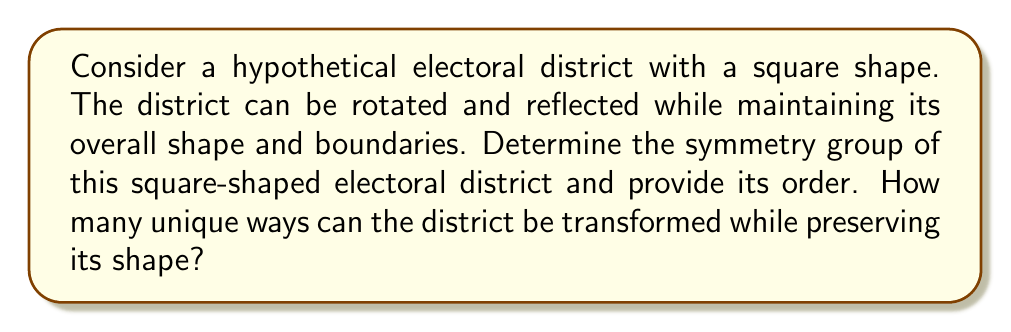Can you solve this math problem? To determine the symmetry group of the square-shaped electoral district, we need to consider all the transformations that preserve its shape and boundaries. Let's approach this step-by-step:

1. Rotational symmetries:
   The square can be rotated by 0°, 90°, 180°, and 270° (or equivalently, 0°, 90°, 180°, and -90°).
   This gives us 4 rotational symmetries.

2. Reflection symmetries:
   The square has 4 lines of reflection:
   - Two diagonal lines
   - One vertical line
   - One horizontal line

3. Combining these symmetries:
   We have 4 rotations and 4 reflections, giving us a total of 8 symmetries.

The symmetry group of a square is known as the dihedral group of order 8, denoted as $D_4$ or $D_8$ (depending on the notation convention).

To represent this group algebraically:
Let $r$ represent a 90° rotation clockwise, and $s$ represent a reflection across the vertical axis.

The elements of the group can be written as:
$$ \{e, r, r^2, r^3, s, sr, sr^2, sr^3\} $$

Where:
- $e$ is the identity transformation
- $r, r^2, r^3$ are rotations by 90°, 180°, and 270° respectively
- $s, sr, sr^2, sr^3$ are reflections across different axes

The group operation table (Cayley table) for this group would be an 8x8 table showing how these elements combine.

The order of this group is 8, which answers the question of how many unique ways the district can be transformed while preserving its shape.

This symmetry group analysis is relevant to electoral district design as it provides insight into the geometric properties of the district shape, which can be important in discussions of fairness and potential gerrymandering in electoral map design.
Answer: The symmetry group of the square-shaped electoral district is the dihedral group $D_4$ (or $D_8$), with an order of 8. There are 8 unique ways the district can be transformed while preserving its shape. 